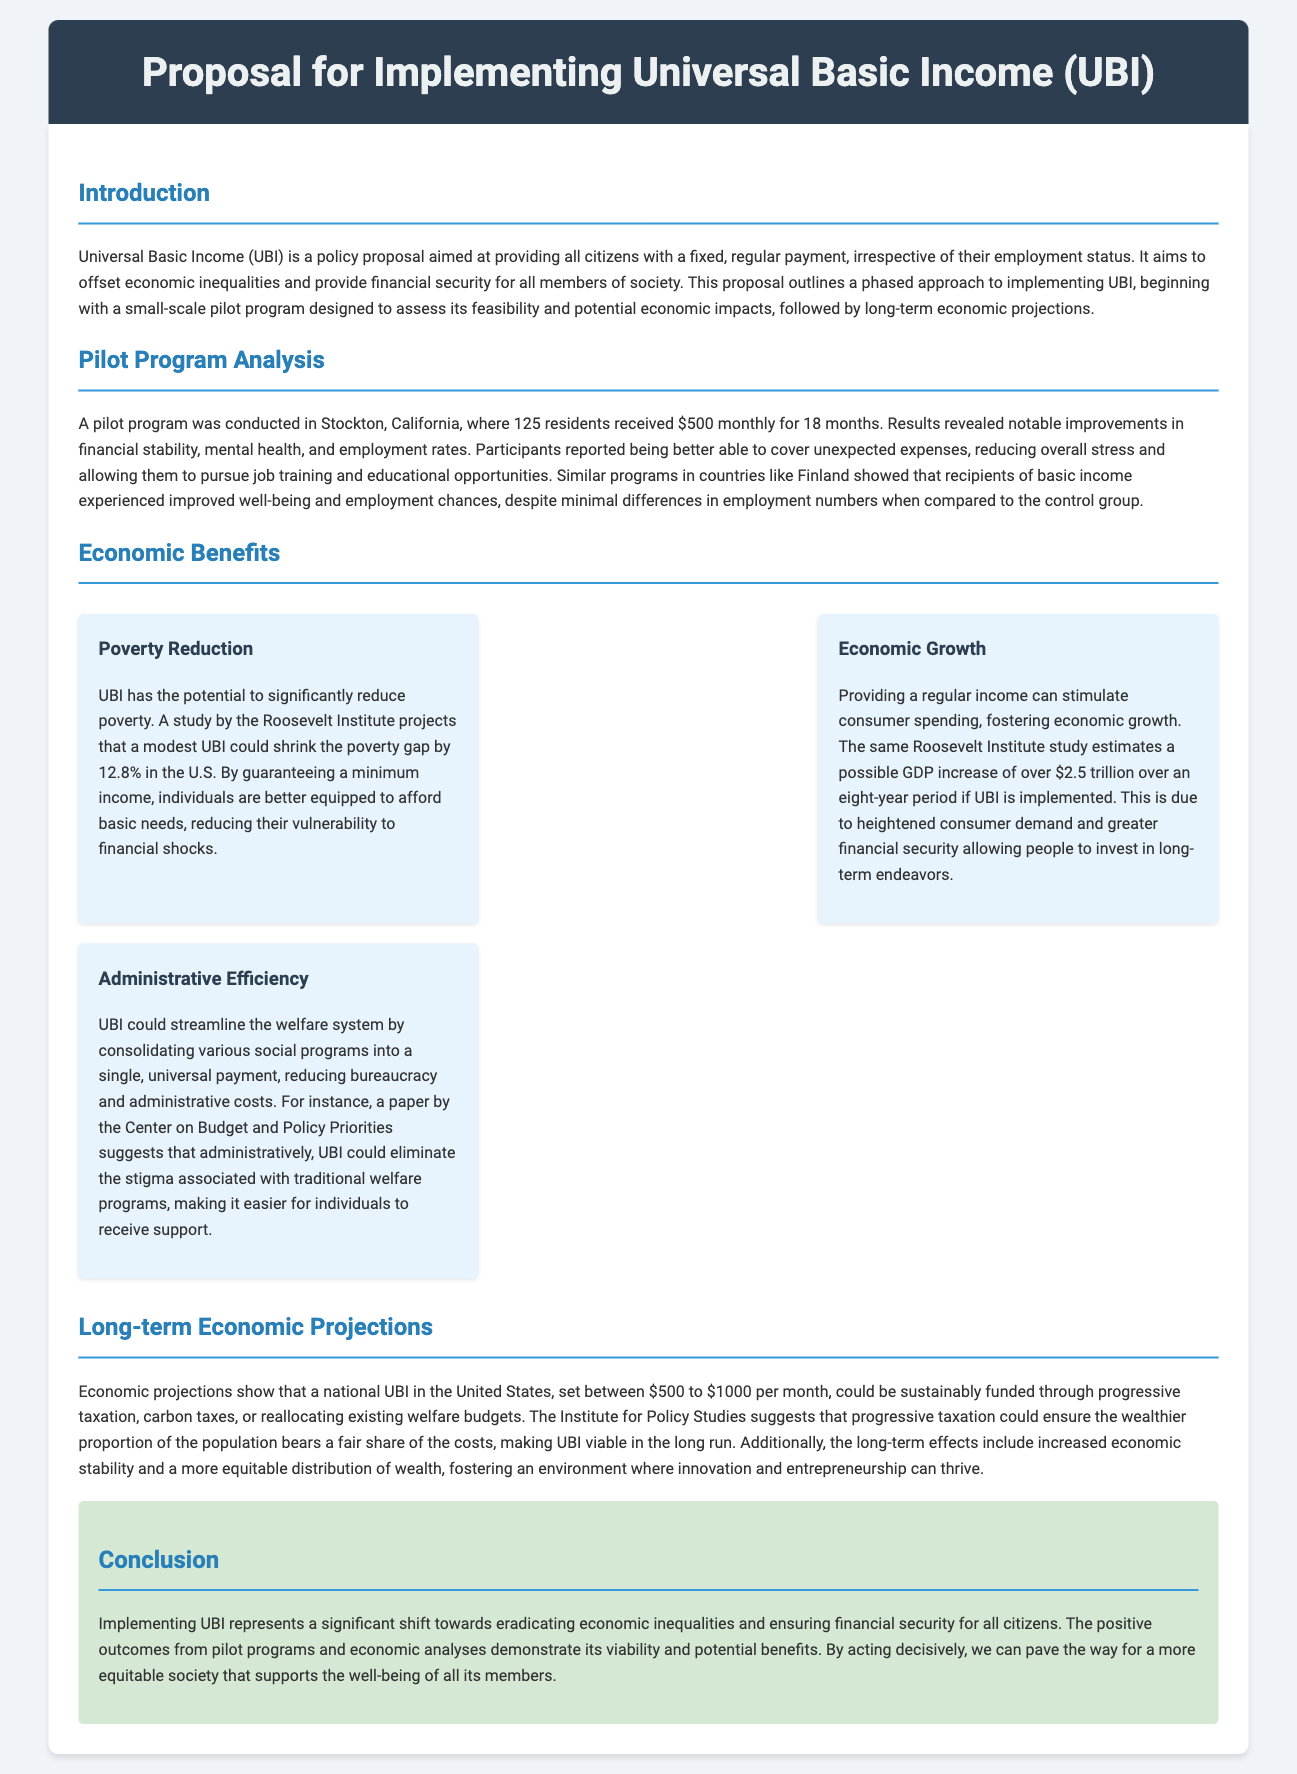What is UBI? UBI stands for Universal Basic Income, a policy proposal aimed at providing all citizens with a fixed, regular payment, irrespective of their employment status.
Answer: Universal Basic Income Where was the pilot program conducted? The pilot program was conducted in Stockton, California.
Answer: Stockton, California How much did participants in the pilot program receive monthly? Participants in the pilot program received $500 monthly.
Answer: $500 What percentage could a modest UBI shrink the poverty gap by? A modest UBI could shrink the poverty gap by 12.8% in the U.S.
Answer: 12.8% What is one potential source of funding for UBI? One potential source of funding for UBI is progressive taxation.
Answer: Progressive taxation What improvements were noted among participants in the pilot program? Notable improvements included financial stability, mental health, and employment rates.
Answer: Financial stability, mental health, and employment rates What is the projected GDP increase if UBI is implemented? The projected GDP increase is over $2.5 trillion over an eight-year period.
Answer: Over $2.5 trillion How long was the pilot program conducted for? The pilot program was conducted for 18 months.
Answer: 18 months What could UBI potentially eliminate in the welfare system? UBI could potentially eliminate the stigma associated with traditional welfare programs.
Answer: Stigma associated with traditional welfare programs 